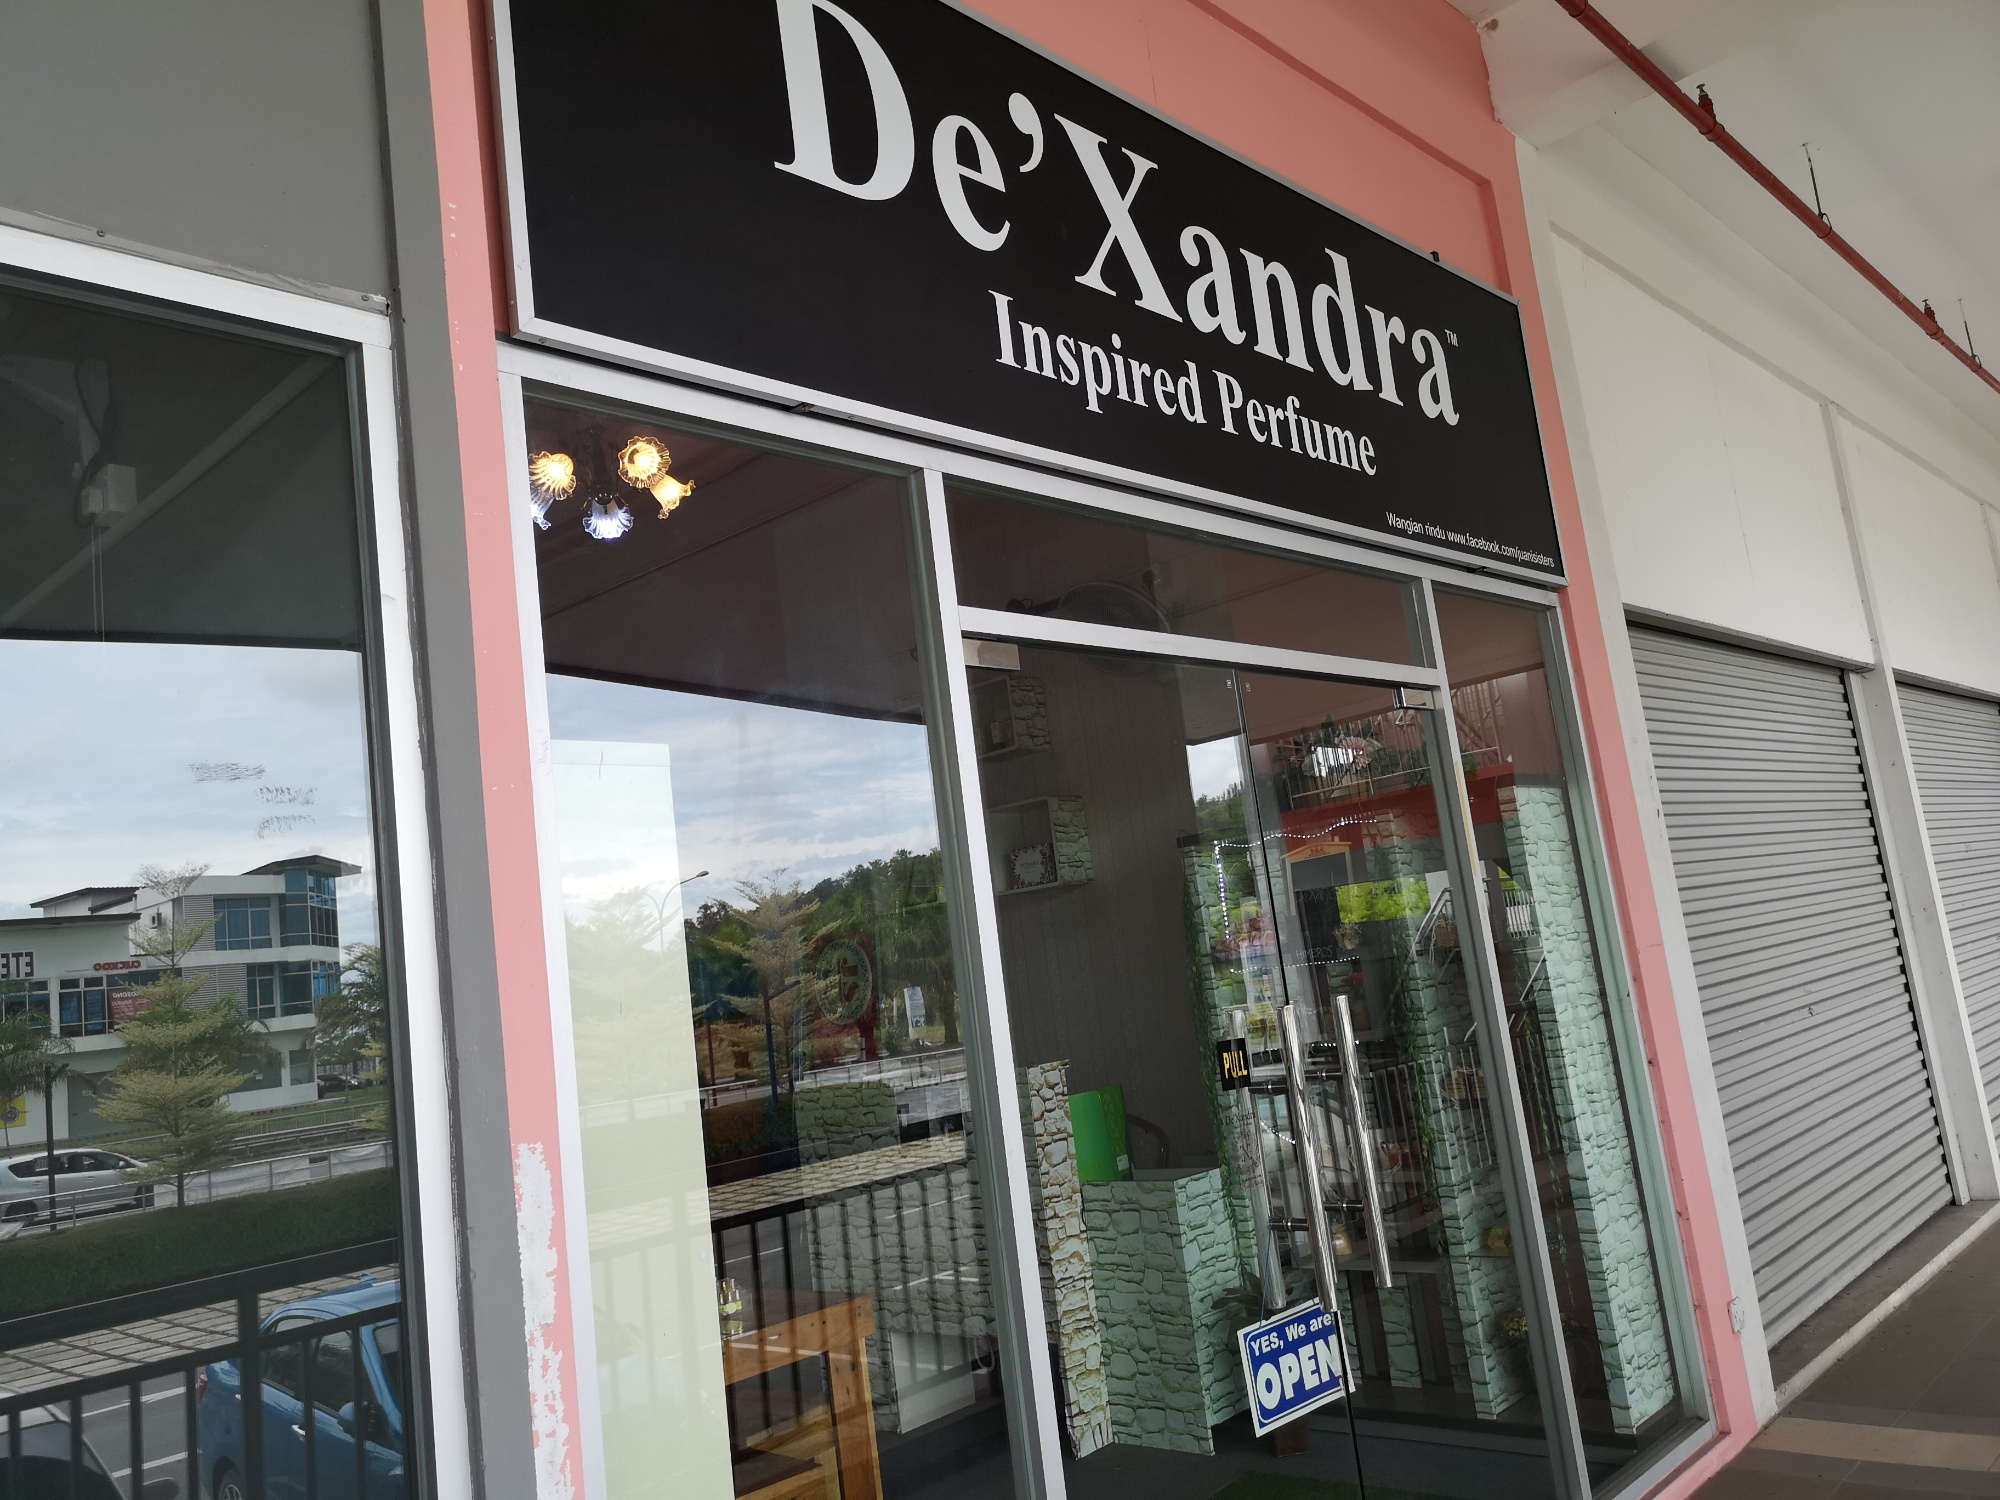How does the store's design contribute to its overall appeal? The store’s design enhances its appeal through a combination of thoughtful elements. The prominent black and pink signage immediately attracts attention, while the clean, modern glass windows and door offer a glimpse into the store, teasing customers with the sight of a well-organized array of perfumes. The 'OPEN' sign is welcoming and invites potential customers in. The neat and spacious area surrounding the store, complete with greenery, creates a tranquil atmosphere that promises a pleasant shopping experience. 